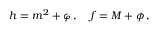Convert formula to latex. <formula><loc_0><loc_0><loc_500><loc_500>h = m ^ { 2 } + \varphi \, , \quad f = M + \phi \, ,</formula> 